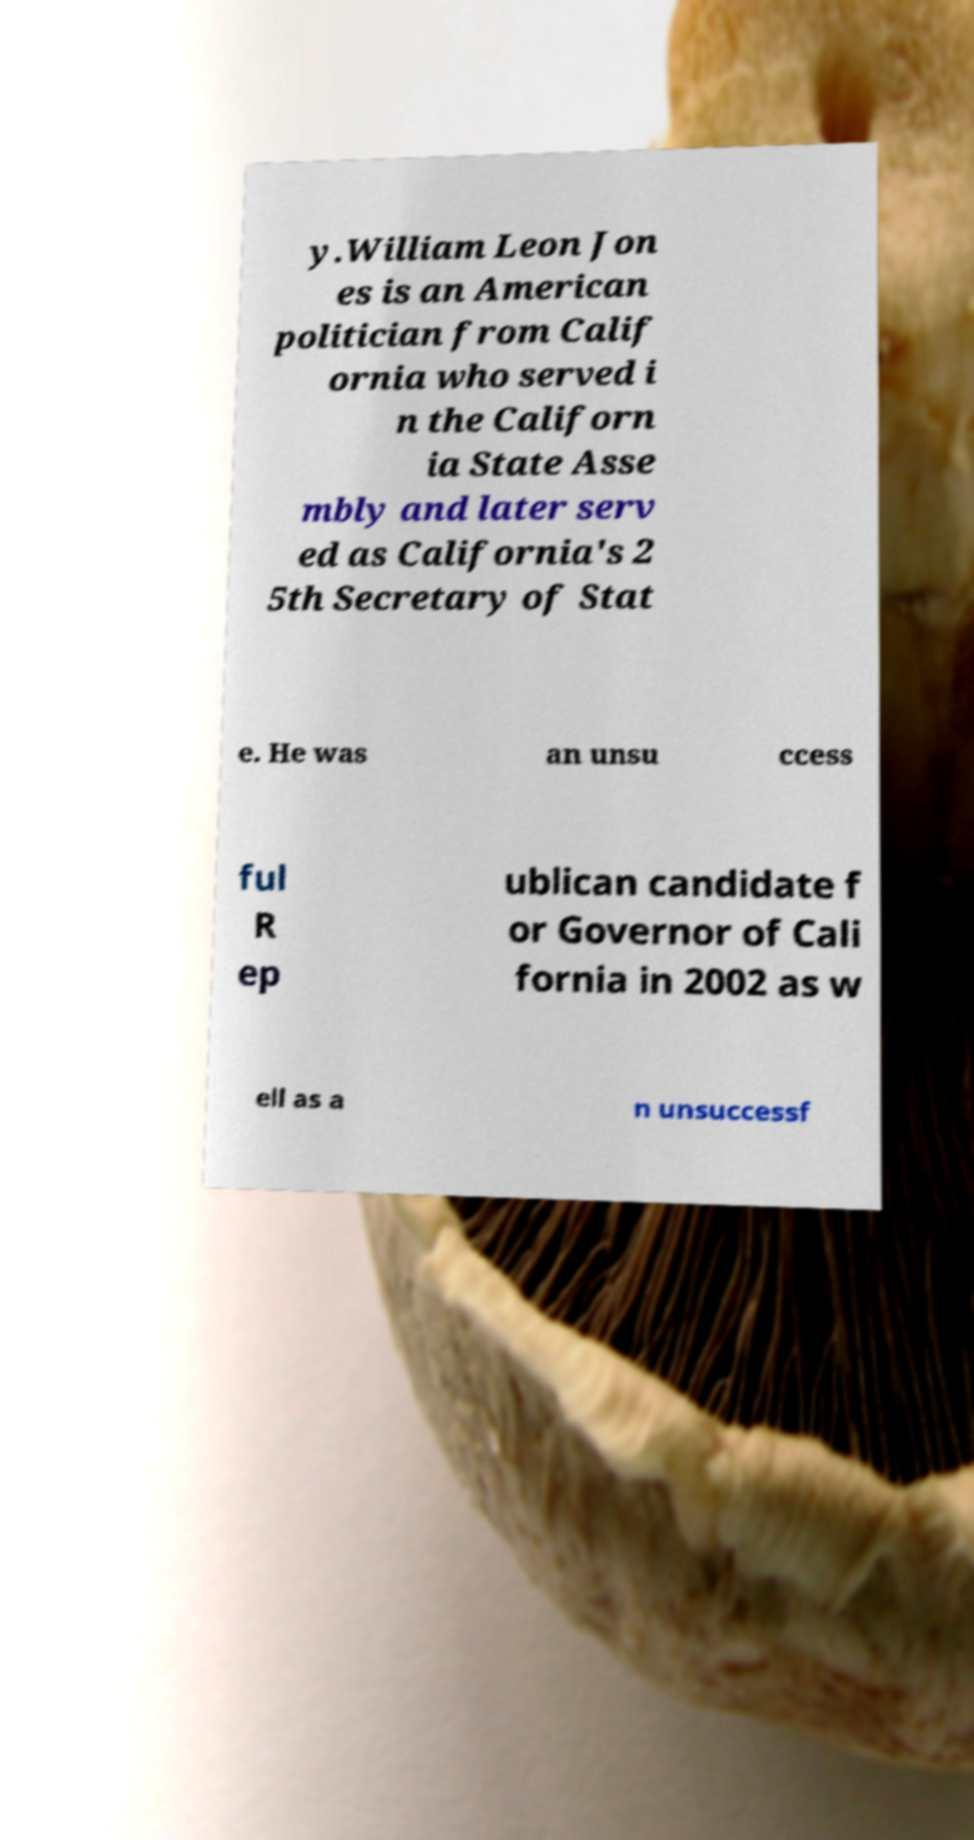What messages or text are displayed in this image? I need them in a readable, typed format. y.William Leon Jon es is an American politician from Calif ornia who served i n the Californ ia State Asse mbly and later serv ed as California's 2 5th Secretary of Stat e. He was an unsu ccess ful R ep ublican candidate f or Governor of Cali fornia in 2002 as w ell as a n unsuccessf 